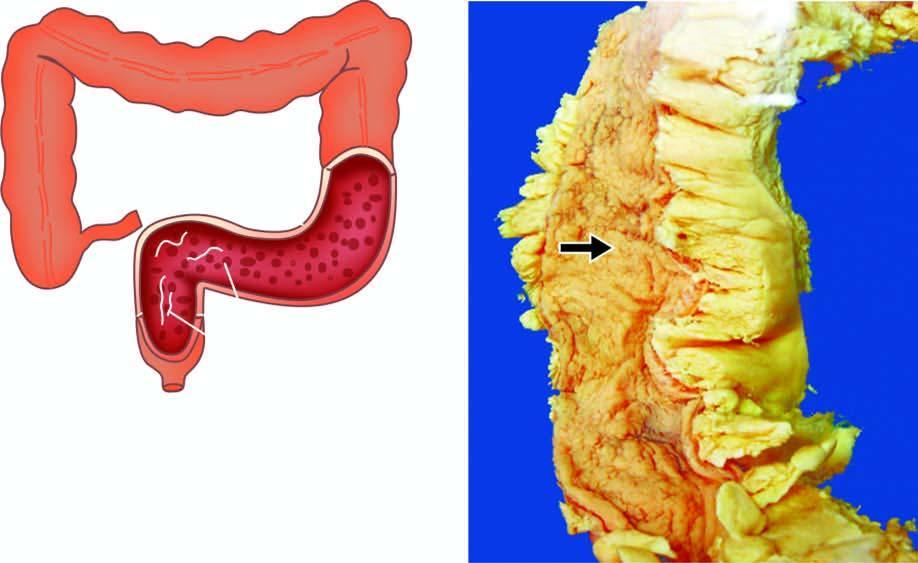what are lost giving 'garden-hose appearance '?
Answer the question using a single word or phrase. Haustral folds 